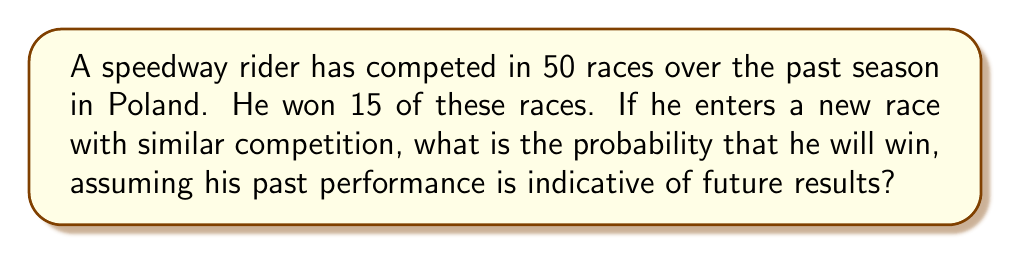What is the answer to this math problem? To solve this problem, we'll use the concept of relative frequency as an estimate of probability. Here's the step-by-step solution:

1) First, we need to calculate the rider's win rate from his past performance.

2) The win rate can be calculated using the formula:

   $$ \text{Win Rate} = \frac{\text{Number of Wins}}{\text{Total Number of Races}} $$

3) We know that:
   - Number of Wins = 15
   - Total Number of Races = 50

4) Substituting these values into our formula:

   $$ \text{Win Rate} = \frac{15}{50} = 0.3 $$

5) This win rate of 0.3 or 30% represents our best estimate of the probability that the rider will win any given race, assuming the conditions and competition are similar to his past races.

6) Therefore, the probability of winning the new race is 0.3 or 30%.
Answer: $0.3$ or $30\%$ 